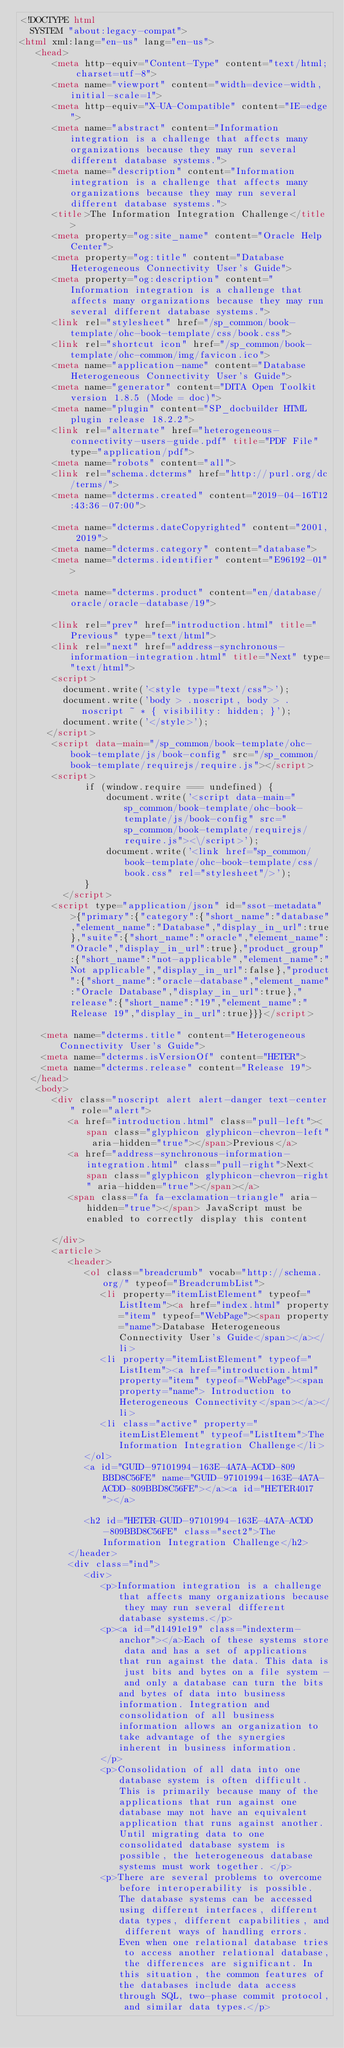Convert code to text. <code><loc_0><loc_0><loc_500><loc_500><_HTML_><!DOCTYPE html
  SYSTEM "about:legacy-compat">
<html xml:lang="en-us" lang="en-us">
   <head>
      <meta http-equiv="Content-Type" content="text/html; charset=utf-8">
      <meta name="viewport" content="width=device-width, initial-scale=1">
      <meta http-equiv="X-UA-Compatible" content="IE=edge">
      <meta name="abstract" content="Information integration is a challenge that affects many organizations because they may run several different database systems.">
      <meta name="description" content="Information integration is a challenge that affects many organizations because they may run several different database systems.">
      <title>The Information Integration Challenge</title>
      <meta property="og:site_name" content="Oracle Help Center">
      <meta property="og:title" content="Database Heterogeneous Connectivity User's Guide">
      <meta property="og:description" content="Information integration is a challenge that affects many organizations because they may run several different database systems.">
      <link rel="stylesheet" href="/sp_common/book-template/ohc-book-template/css/book.css">
      <link rel="shortcut icon" href="/sp_common/book-template/ohc-common/img/favicon.ico">
      <meta name="application-name" content="Database Heterogeneous Connectivity User's Guide">
      <meta name="generator" content="DITA Open Toolkit version 1.8.5 (Mode = doc)">
      <meta name="plugin" content="SP_docbuilder HTML plugin release 18.2.2">
      <link rel="alternate" href="heterogeneous-connectivity-users-guide.pdf" title="PDF File" type="application/pdf">
      <meta name="robots" content="all">
      <link rel="schema.dcterms" href="http://purl.org/dc/terms/">
      <meta name="dcterms.created" content="2019-04-16T12:43:36-07:00">
      
      <meta name="dcterms.dateCopyrighted" content="2001, 2019">
      <meta name="dcterms.category" content="database">
      <meta name="dcterms.identifier" content="E96192-01">
      
      <meta name="dcterms.product" content="en/database/oracle/oracle-database/19">
      
      <link rel="prev" href="introduction.html" title="Previous" type="text/html">
      <link rel="next" href="address-synchronous-information-integration.html" title="Next" type="text/html">
      <script>
        document.write('<style type="text/css">');
        document.write('body > .noscript, body > .noscript ~ * { visibility: hidden; }');
        document.write('</style>');
     </script>
      <script data-main="/sp_common/book-template/ohc-book-template/js/book-config" src="/sp_common/book-template/requirejs/require.js"></script>
      <script>
            if (window.require === undefined) {
                document.write('<script data-main="sp_common/book-template/ohc-book-template/js/book-config" src="sp_common/book-template/requirejs/require.js"><\/script>');
                document.write('<link href="sp_common/book-template/ohc-book-template/css/book.css" rel="stylesheet"/>');
            }
        </script>
      <script type="application/json" id="ssot-metadata">{"primary":{"category":{"short_name":"database","element_name":"Database","display_in_url":true},"suite":{"short_name":"oracle","element_name":"Oracle","display_in_url":true},"product_group":{"short_name":"not-applicable","element_name":"Not applicable","display_in_url":false},"product":{"short_name":"oracle-database","element_name":"Oracle Database","display_in_url":true},"release":{"short_name":"19","element_name":"Release 19","display_in_url":true}}}</script>
      
    <meta name="dcterms.title" content="Heterogeneous Connectivity User's Guide">
    <meta name="dcterms.isVersionOf" content="HETER">
    <meta name="dcterms.release" content="Release 19">
  </head>
   <body>
      <div class="noscript alert alert-danger text-center" role="alert">
         <a href="introduction.html" class="pull-left"><span class="glyphicon glyphicon-chevron-left" aria-hidden="true"></span>Previous</a>
         <a href="address-synchronous-information-integration.html" class="pull-right">Next<span class="glyphicon glyphicon-chevron-right" aria-hidden="true"></span></a>
         <span class="fa fa-exclamation-triangle" aria-hidden="true"></span> JavaScript must be enabled to correctly display this content
        
      </div>
      <article>
         <header>
            <ol class="breadcrumb" vocab="http://schema.org/" typeof="BreadcrumbList">
               <li property="itemListElement" typeof="ListItem"><a href="index.html" property="item" typeof="WebPage"><span property="name">Database Heterogeneous Connectivity User's Guide</span></a></li>
               <li property="itemListElement" typeof="ListItem"><a href="introduction.html" property="item" typeof="WebPage"><span property="name"> Introduction to Heterogeneous Connectivity</span></a></li>
               <li class="active" property="itemListElement" typeof="ListItem">The Information Integration Challenge</li>
            </ol>
            <a id="GUID-97101994-163E-4A7A-ACDD-809BBD8C56FE" name="GUID-97101994-163E-4A7A-ACDD-809BBD8C56FE"></a><a id="HETER4017"></a>
            
            <h2 id="HETER-GUID-97101994-163E-4A7A-ACDD-809BBD8C56FE" class="sect2">The Information Integration Challenge</h2>
         </header>
         <div class="ind">
            <div>
               <p>Information integration is a challenge that affects many organizations because they may run several different database systems.</p>
               <p><a id="d1491e19" class="indexterm-anchor"></a>Each of these systems store data and has a set of applications that run against the data. This data is just bits and bytes on a file system - and only a database can turn the bits and bytes of data into business information. Integration and consolidation of all business information allows an organization to take advantage of the synergies inherent in business information. 
               </p>
               <p>Consolidation of all data into one database system is often difficult. This is primarily because many of the applications that run against one database may not have an equivalent application that runs against another. Until migrating data to one consolidated database system is possible, the heterogeneous database systems must work together. </p>
               <p>There are several problems to overcome before interoperability is possible. The database systems can be accessed using different interfaces, different data types, different capabilities, and different ways of handling errors. Even when one relational database tries to access another relational database, the differences are significant. In this situation, the common features of the databases include data access through SQL, two-phase commit protocol, and similar data types.</p></code> 